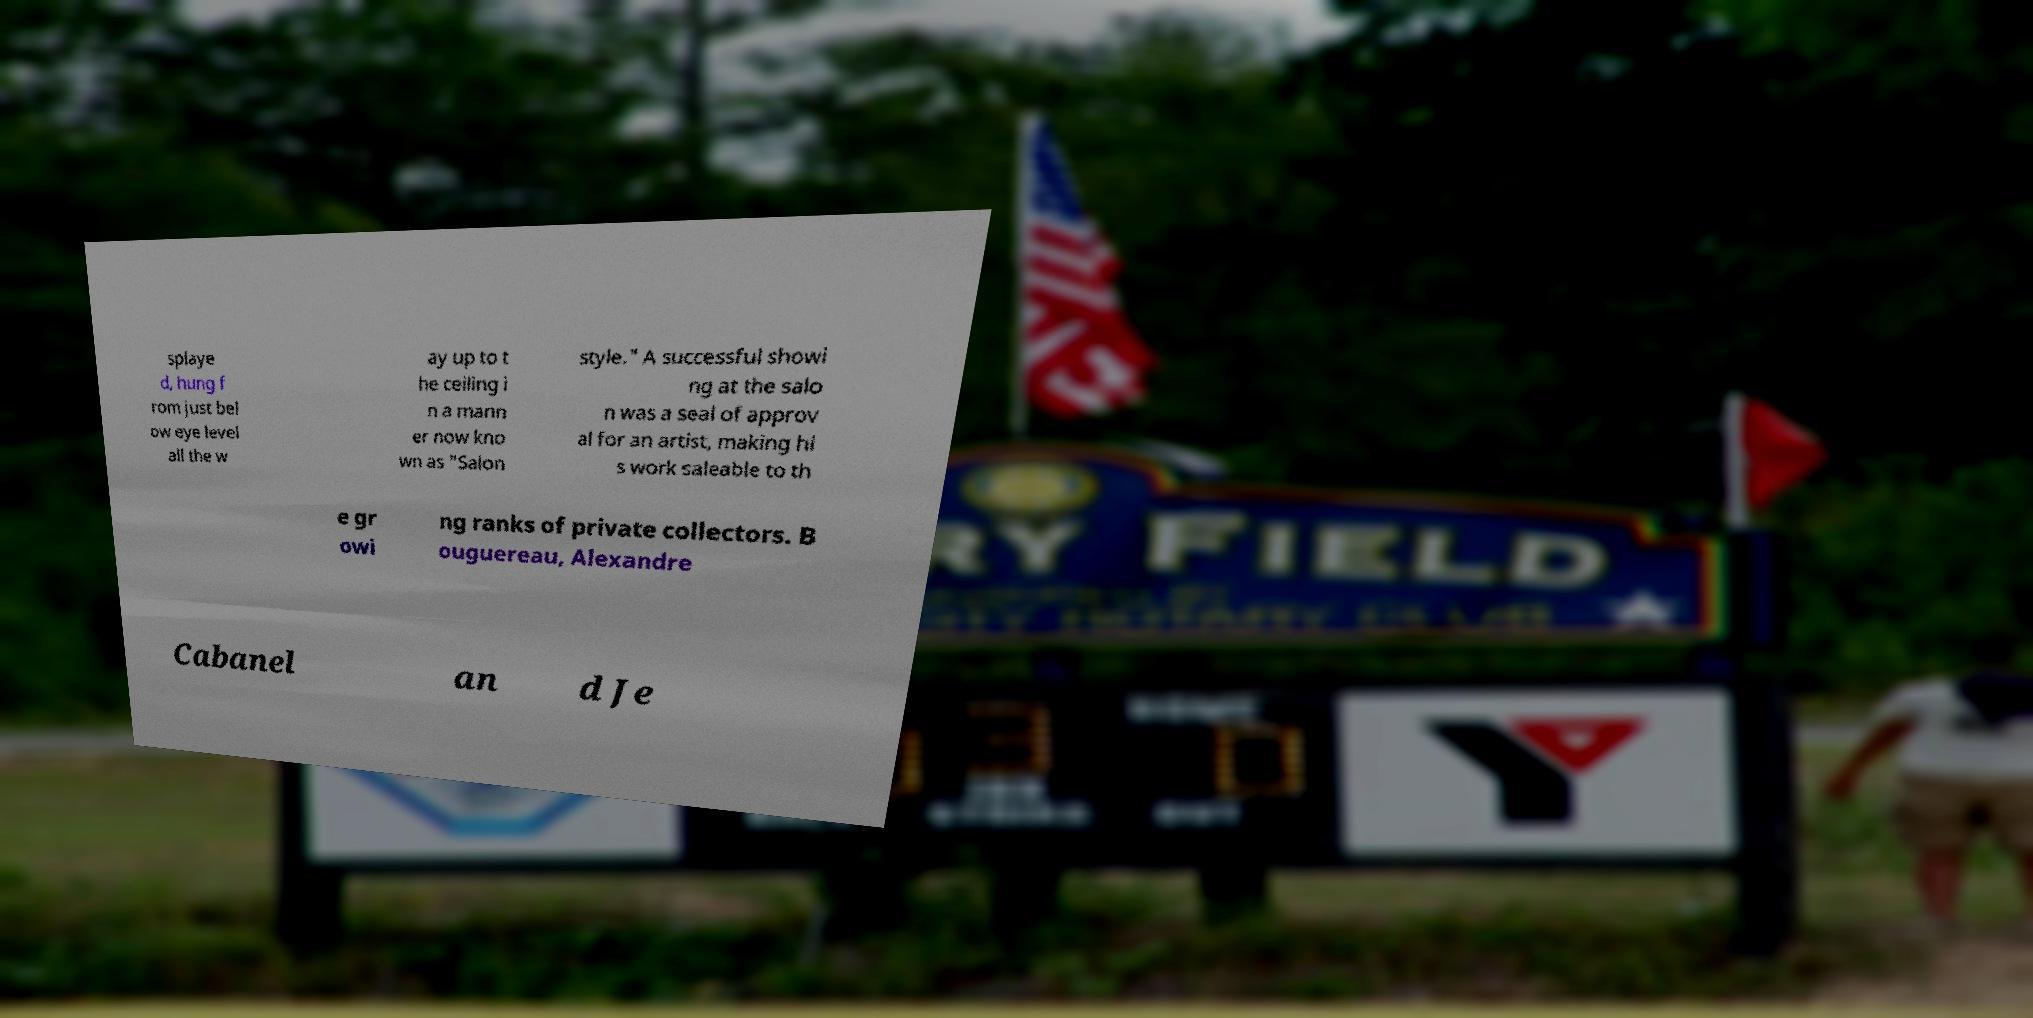There's text embedded in this image that I need extracted. Can you transcribe it verbatim? splaye d, hung f rom just bel ow eye level all the w ay up to t he ceiling i n a mann er now kno wn as "Salon style." A successful showi ng at the salo n was a seal of approv al for an artist, making hi s work saleable to th e gr owi ng ranks of private collectors. B ouguereau, Alexandre Cabanel an d Je 